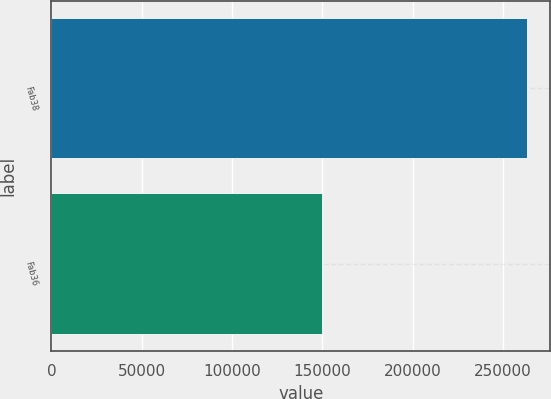<chart> <loc_0><loc_0><loc_500><loc_500><bar_chart><fcel>Fab38<fcel>Fab36<nl><fcel>263000<fcel>150000<nl></chart> 